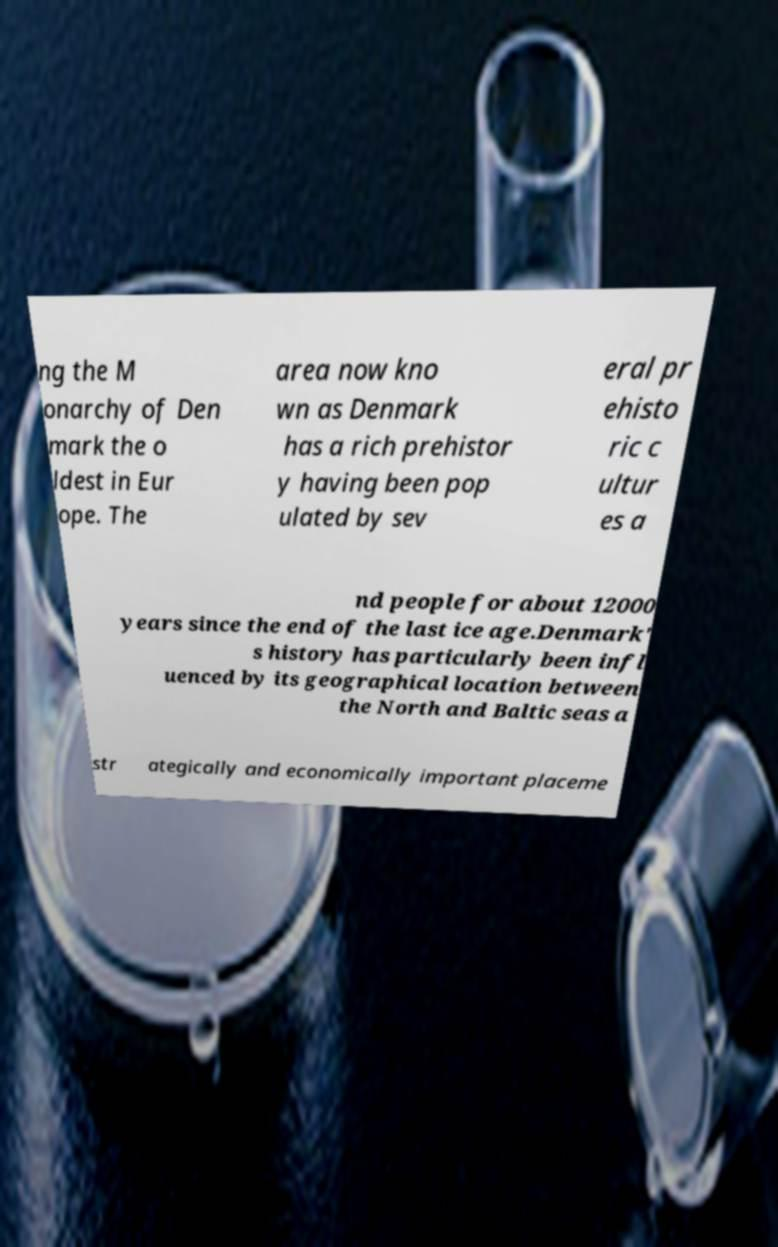Can you accurately transcribe the text from the provided image for me? ng the M onarchy of Den mark the o ldest in Eur ope. The area now kno wn as Denmark has a rich prehistor y having been pop ulated by sev eral pr ehisto ric c ultur es a nd people for about 12000 years since the end of the last ice age.Denmark' s history has particularly been infl uenced by its geographical location between the North and Baltic seas a str ategically and economically important placeme 